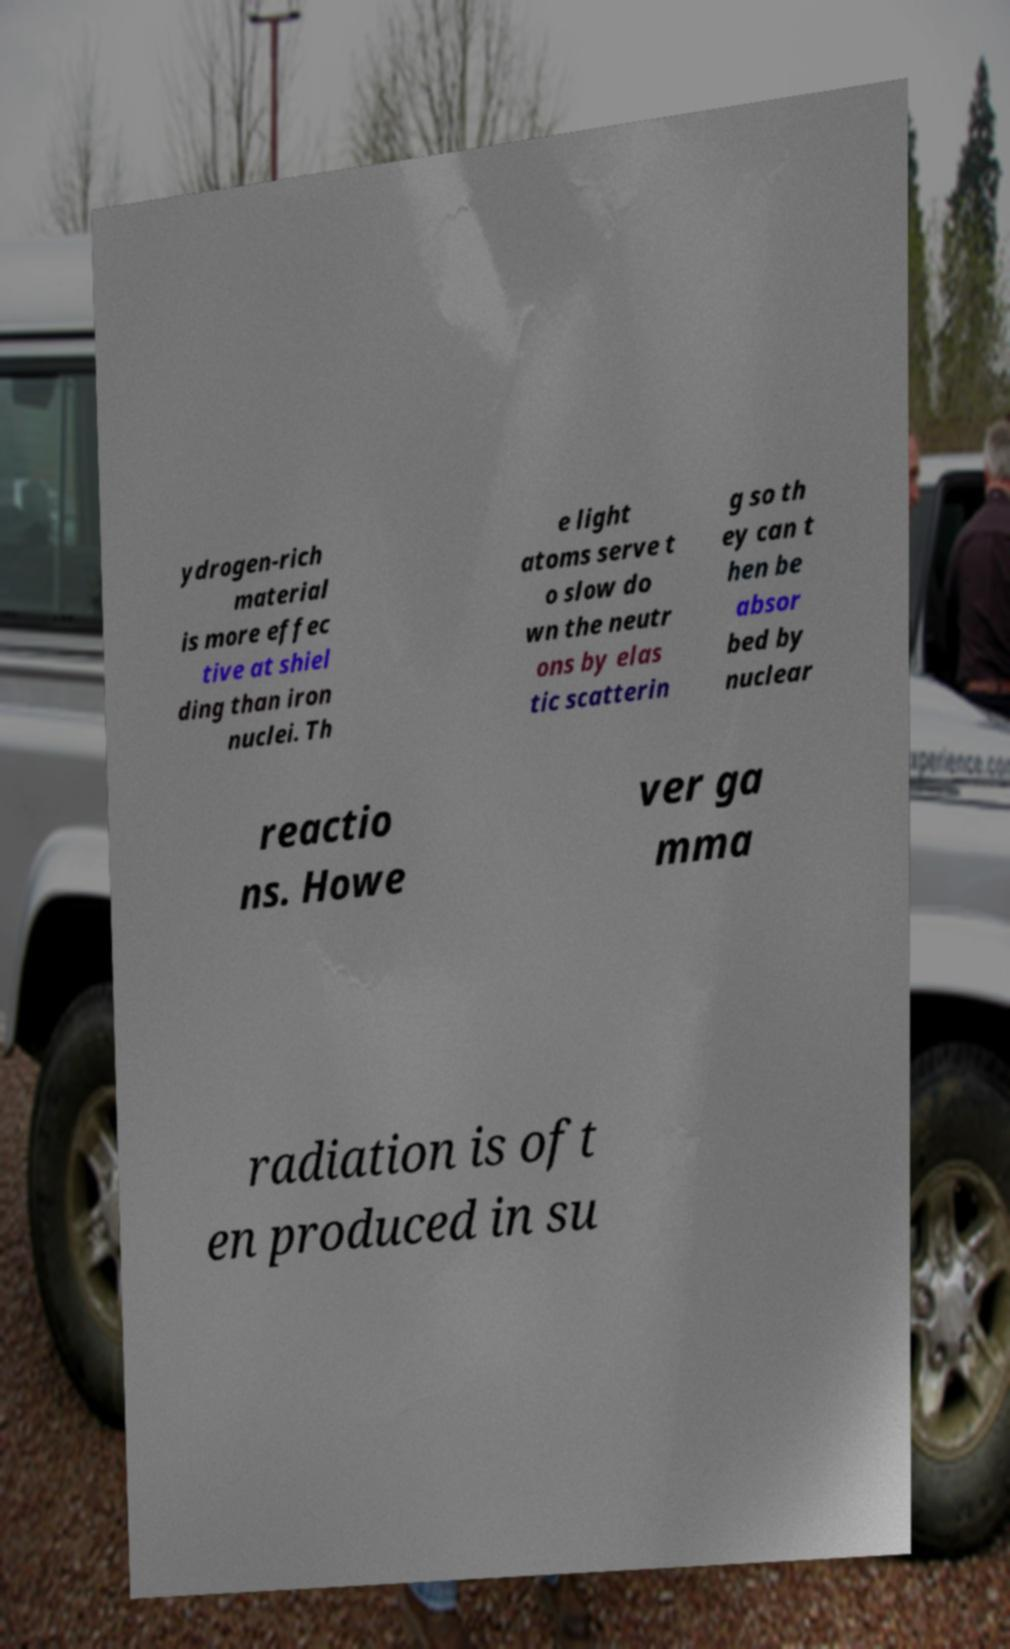For documentation purposes, I need the text within this image transcribed. Could you provide that? ydrogen-rich material is more effec tive at shiel ding than iron nuclei. Th e light atoms serve t o slow do wn the neutr ons by elas tic scatterin g so th ey can t hen be absor bed by nuclear reactio ns. Howe ver ga mma radiation is oft en produced in su 